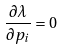<formula> <loc_0><loc_0><loc_500><loc_500>\frac { \partial \lambda } { \partial p _ { i } } = 0</formula> 